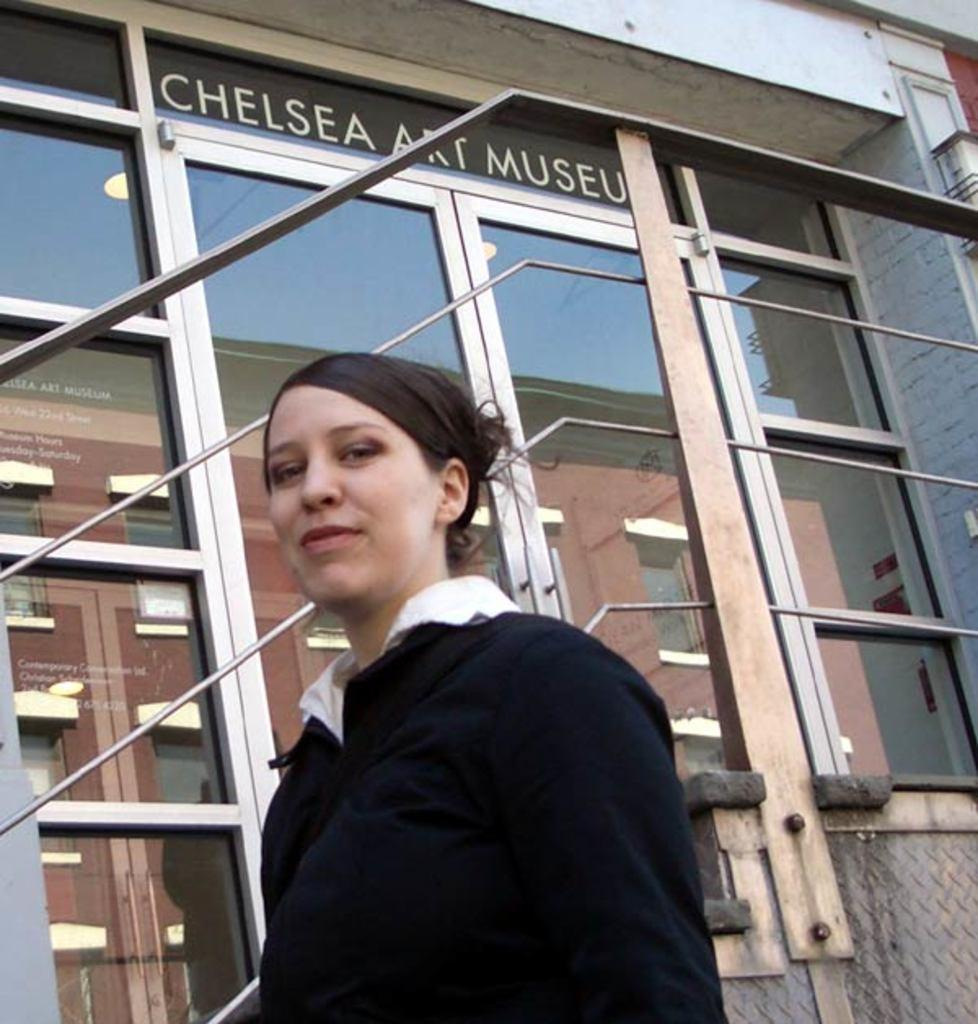Who is present in the image? There is a woman in the image. What is the woman doing in the image? The woman is standing and smiling. What is the woman wearing in the image? The woman is wearing a black dress. What can be seen in the background of the image? There is a building in the background of the image. What are the characteristics of the building in the image? The building has glass windows and the name "Chelsea Art Museum" on it. What type of scale can be seen in the image? There is no scale present in the image. What color is the woman's underwear in the image? The woman's underwear is not visible in the image, as she is wearing a black dress. 